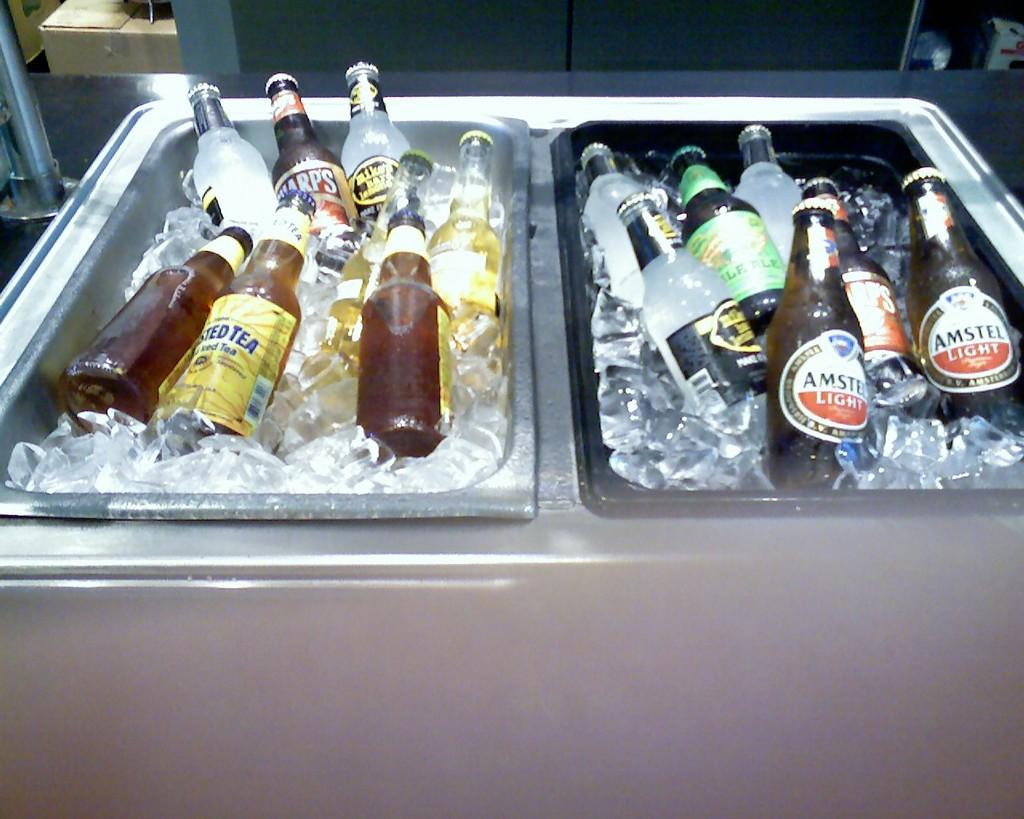<image>
Give a short and clear explanation of the subsequent image. Amstel Light Beer and Mike's lemoade alcohol in a freezer 